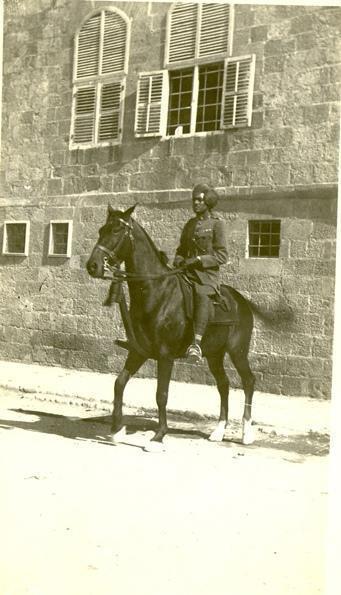How many doors are on the building?
Give a very brief answer. 0. How many open umbrellas are there?
Give a very brief answer. 0. 